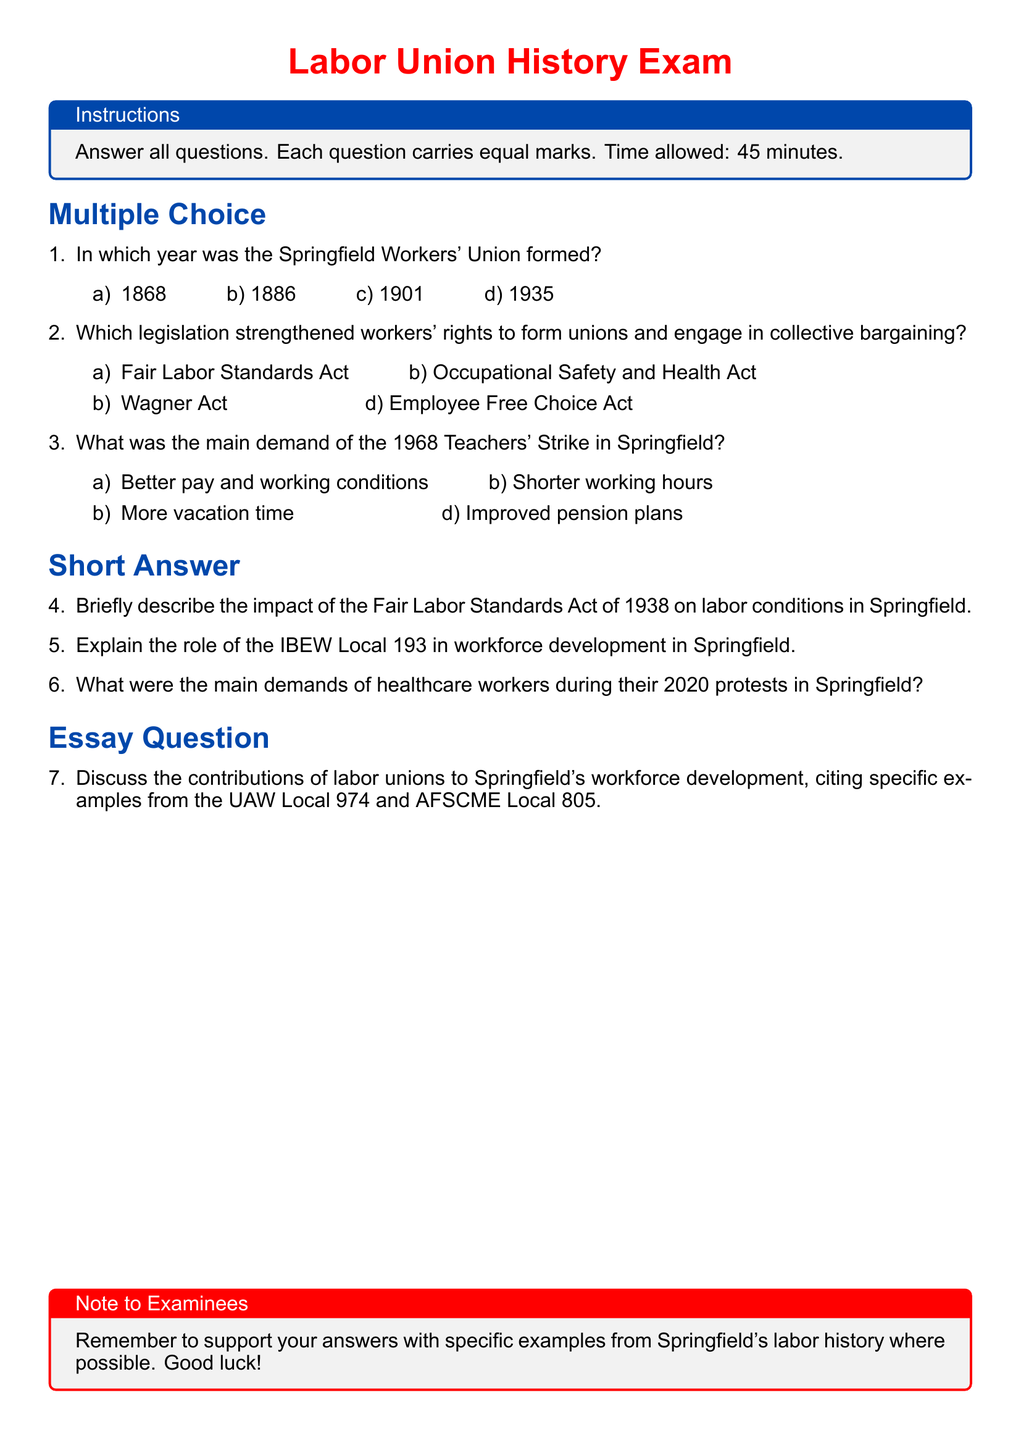What year was the Springfield Workers' Union formed? The document states that the Springfield Workers' Union was formed in one of the multiple-choice options, which is 1886.
Answer: 1886 Which legislation strengthened workers' rights? According to the multiple-choice section, the legislation that strengthened workers' rights is the Wagner Act.
Answer: Wagner Act What was the primary demand during the 1968 Teachers' Strike? The document mentions that the main demand was better pay and working conditions in one of the choices.
Answer: Better pay and working conditions What Act was mentioned in relation to labor conditions in Springfield? The Fair Labor Standards Act of 1938 is referenced in the short-answer section as impacting labor conditions.
Answer: Fair Labor Standards Act of 1938 Which union is specifically mentioned for its role in workforce development? The International Brotherhood of Electrical Workers (IBEW) Local 193 is referenced in the short-answer questions regarding workforce development.
Answer: IBEW Local 193 What year did healthcare workers protest in Springfield? The short-answer question refers to the protests by healthcare workers occurring in 2020.
Answer: 2020 What is the format of the exam discussed in the document? The document outlines that it's a labor union history exam, specifically mentioning multiple-choice and short-answer sections.
Answer: Labor Union History Exam Which two unions are mentioned in the essay question? The essay question cites UAW Local 974 and AFSCME Local 805 as significant unions in Springfield.
Answer: UAW Local 974 and AFSCME Local 805 